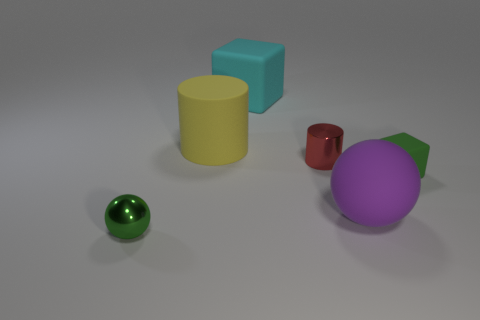Add 3 large gray objects. How many objects exist? 9 Subtract all cylinders. How many objects are left? 4 Add 3 green blocks. How many green blocks exist? 4 Subtract 0 purple cubes. How many objects are left? 6 Subtract all tiny red shiny cylinders. Subtract all tiny shiny things. How many objects are left? 3 Add 3 purple things. How many purple things are left? 4 